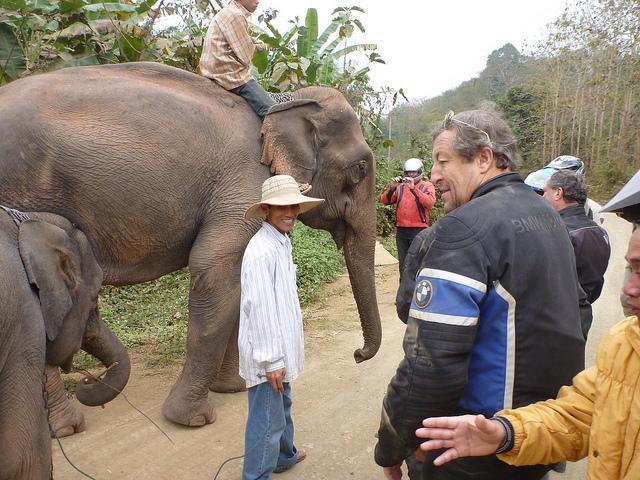Which of these men is most likely from a different country?
Select the correct answer and articulate reasoning with the following format: 'Answer: answer
Rationale: rationale.'
Options: Plaid shirt, bmw jacket, yellow shirt, striped shirt. Answer: bmw jacket.
Rationale: The men in the yellow, striped, and plaid shirts all have a similar skin colour. 